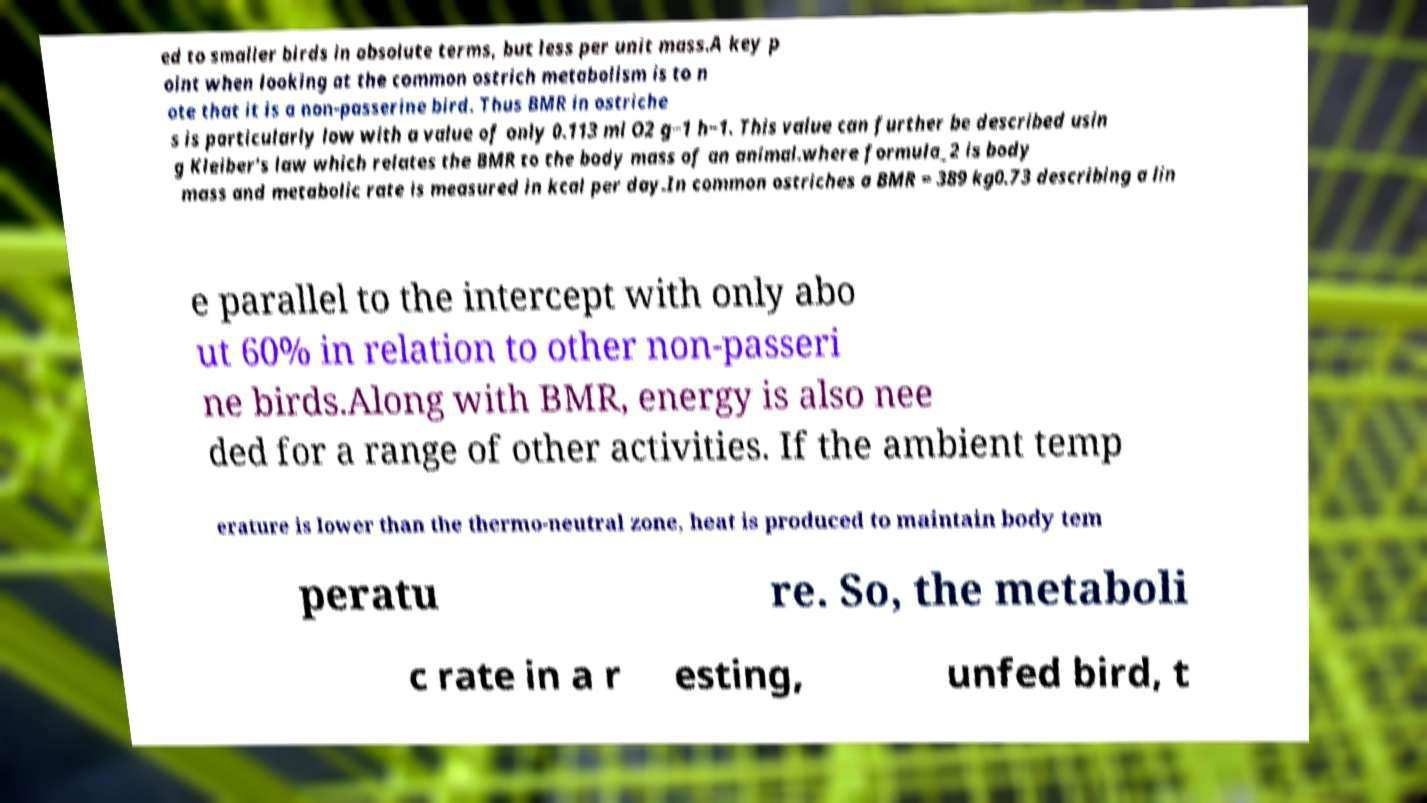There's text embedded in this image that I need extracted. Can you transcribe it verbatim? ed to smaller birds in absolute terms, but less per unit mass.A key p oint when looking at the common ostrich metabolism is to n ote that it is a non-passerine bird. Thus BMR in ostriche s is particularly low with a value of only 0.113 ml O2 g−1 h−1. This value can further be described usin g Kleiber's law which relates the BMR to the body mass of an animal.where formula_2 is body mass and metabolic rate is measured in kcal per day.In common ostriches a BMR = 389 kg0.73 describing a lin e parallel to the intercept with only abo ut 60% in relation to other non-passeri ne birds.Along with BMR, energy is also nee ded for a range of other activities. If the ambient temp erature is lower than the thermo-neutral zone, heat is produced to maintain body tem peratu re. So, the metaboli c rate in a r esting, unfed bird, t 